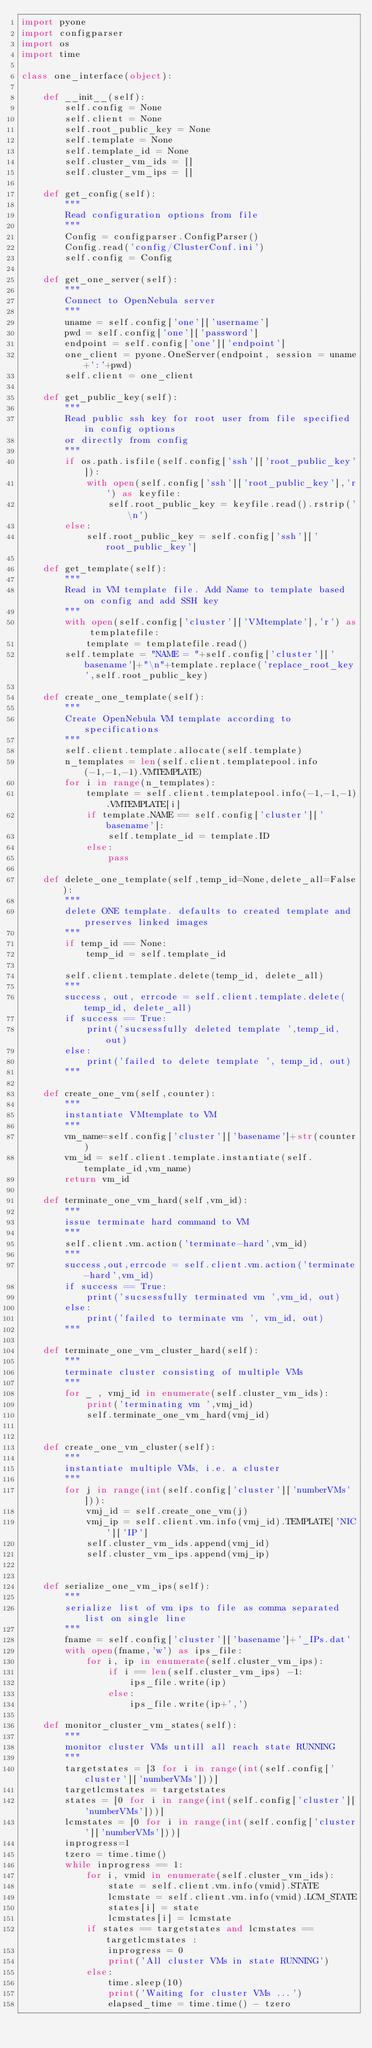<code> <loc_0><loc_0><loc_500><loc_500><_Python_>import pyone
import configparser
import os
import time

class one_interface(object):

    def __init__(self):
        self.config = None
        self.client = None
        self.root_public_key = None
        self.template = None
        self.template_id = None
        self.cluster_vm_ids = []
        self.cluster_vm_ips = []

    def get_config(self):
        """
        Read configuration options from file
        """
        Config = configparser.ConfigParser()
        Config.read('config/ClusterConf.ini')
        self.config = Config

    def get_one_server(self):
        """
        Connect to OpenNebula server
        """
        uname = self.config['one']['username']
        pwd = self.config['one']['password']
        endpoint = self.config['one']['endpoint']
        one_client = pyone.OneServer(endpoint, session = uname+':'+pwd)
        self.client = one_client

    def get_public_key(self):
        """
        Read public ssh key for root user from file specified in config options
        or directly from config
        """
        if os.path.isfile(self.config['ssh']['root_public_key']):
            with open(self.config['ssh']['root_public_key'],'r') as keyfile:
                self.root_public_key = keyfile.read().rstrip('\n')
        else:
            self.root_public_key = self.config['ssh']['root_public_key']

    def get_template(self):
        """
        Read in VM template file. Add Name to template based on config and add SSH key
        """
        with open(self.config['cluster']['VMtemplate'],'r') as templatefile:
            template = templatefile.read()
        self.template = "NAME = "+self.config['cluster']['basename']+"\n"+template.replace('replace_root_key',self.root_public_key)

    def create_one_template(self):
        """
        Create OpenNebula VM template according to specifications
        """
        self.client.template.allocate(self.template)
        n_templates = len(self.client.templatepool.info(-1,-1,-1).VMTEMPLATE)
        for i in range(n_templates):
            template = self.client.templatepool.info(-1,-1,-1).VMTEMPLATE[i]
            if template.NAME == self.config['cluster']['basename']:
                self.template_id = template.ID
            else:
                pass

    def delete_one_template(self,temp_id=None,delete_all=False):
        """
        delete ONE template. defaults to created template and preserves linked images
        """
        if temp_id == None:
            temp_id = self.template_id

        self.client.template.delete(temp_id, delete_all)
        """
        success, out, errcode = self.client.template.delete(temp_id, delete_all)
        if success == True:
            print('sucsessfully deleted template ',temp_id, out)
        else:
            print('failed to delete template ', temp_id, out)
        """

    def create_one_vm(self,counter):
        """
        instantiate VMtemplate to VM
        """
        vm_name=self.config['cluster']['basename']+str(counter)
        vm_id = self.client.template.instantiate(self.template_id,vm_name)
        return vm_id

    def terminate_one_vm_hard(self,vm_id):
        """
        issue terminate hard command to VM
        """
        self.client.vm.action('terminate-hard',vm_id)
        """
        success,out,errcode = self.client.vm.action('terminate-hard',vm_id)
        if success == True:
            print('sucsessfully terminated vm ',vm_id, out)
        else:
            print('failed to terminate vm ', vm_id, out)
        """

    def terminate_one_vm_cluster_hard(self):
        """
        terminate cluster consisting of multiple VMs
        """
        for _ , vmj_id in enumerate(self.cluster_vm_ids):
            print('terminating vm ',vmj_id)
            self.terminate_one_vm_hard(vmj_id)


    def create_one_vm_cluster(self):
        """
        instantiate multiple VMs, i.e. a cluster
        """
        for j in range(int(self.config['cluster']['numberVMs'])):
            vmj_id = self.create_one_vm(j)
            vmj_ip = self.client.vm.info(vmj_id).TEMPLATE['NIC']['IP']
            self.cluster_vm_ids.append(vmj_id)
            self.cluster_vm_ips.append(vmj_ip)


    def serialize_one_vm_ips(self):
        """
        serialize list of vm ips to file as comma separated list on single line
        """
        fname = self.config['cluster']['basename']+'_IPs.dat'
        with open(fname,'w') as ips_file:
            for i, ip in enumerate(self.cluster_vm_ips):
                if i == len(self.cluster_vm_ips) -1:
                    ips_file.write(ip)
                else:
                    ips_file.write(ip+',')

    def monitor_cluster_vm_states(self):
        """
        monitor cluster VMs untill all reach state RUNNING
        """
        targetstates = [3 for i in range(int(self.config['cluster']['numberVMs']))]
        targetlcmstates = targetstates
        states = [0 for i in range(int(self.config['cluster']['numberVMs']))]
        lcmstates = [0 for i in range(int(self.config['cluster']['numberVMs']))]
        inprogress=1
        tzero = time.time()
        while inprogress == 1:
            for i, vmid in enumerate(self.cluster_vm_ids):
                state = self.client.vm.info(vmid).STATE
                lcmstate = self.client.vm.info(vmid).LCM_STATE
                states[i] = state
                lcmstates[i] = lcmstate
            if states == targetstates and lcmstates == targetlcmstates :
                inprogress = 0
                print('All cluster VMs in state RUNNING')
            else:
                time.sleep(10)
                print('Waiting for cluster VMs ...')
                elapsed_time = time.time() - tzero</code> 